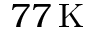Convert formula to latex. <formula><loc_0><loc_0><loc_500><loc_500>7 7 \, K</formula> 